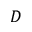Convert formula to latex. <formula><loc_0><loc_0><loc_500><loc_500>D</formula> 